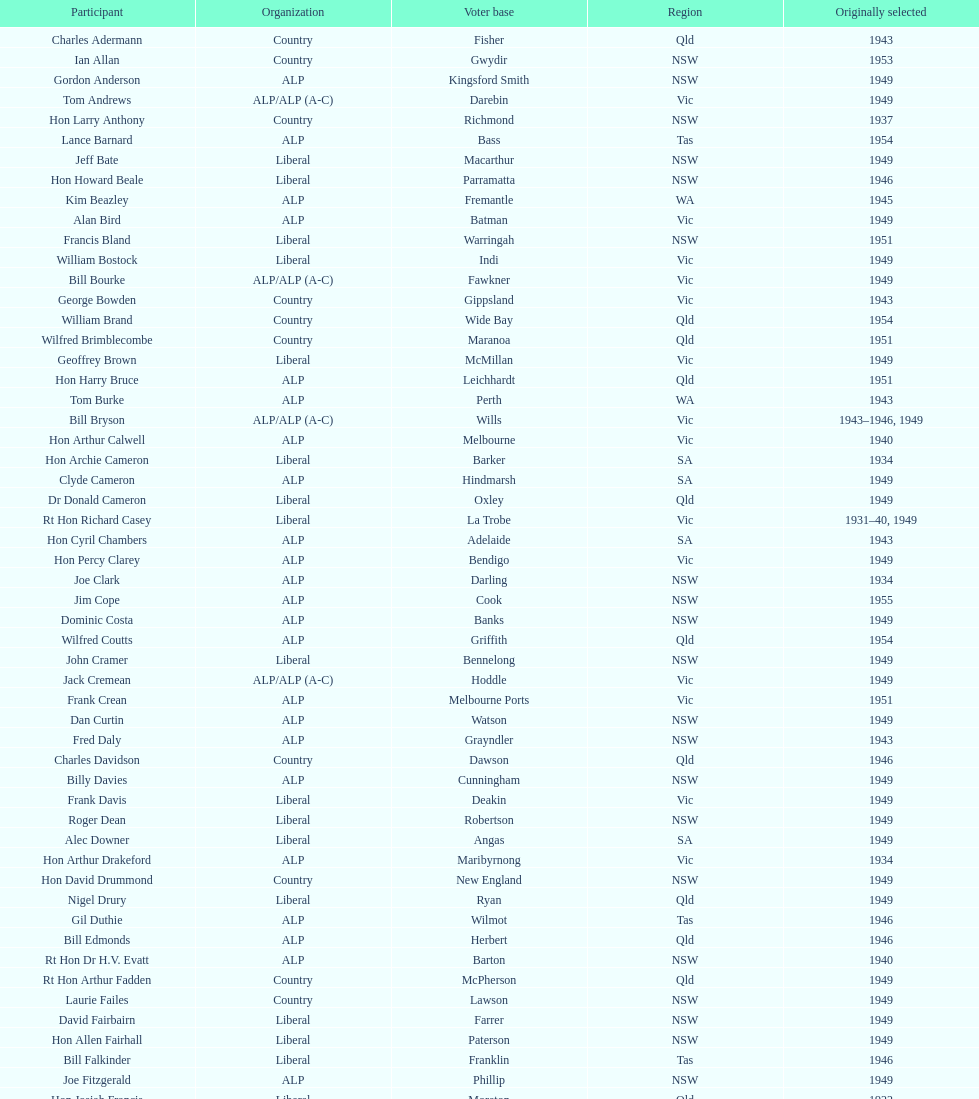After tom burke was elected, what was the next year where another tom would be elected? 1937. 